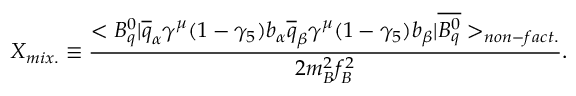<formula> <loc_0><loc_0><loc_500><loc_500>X _ { m i x . } \equiv \frac { < B _ { q } ^ { 0 } | \overline { q } _ { \alpha } \gamma ^ { \mu } ( 1 - \gamma _ { 5 } ) b _ { \alpha } \overline { q } _ { \beta } \gamma ^ { \mu } ( 1 - \gamma _ { 5 } ) b _ { \beta } | \overline { { { B _ { q } ^ { 0 } } } } > _ { n o n - f a c t . } } { 2 m _ { B } ^ { 2 } f _ { B } ^ { 2 } } .</formula> 